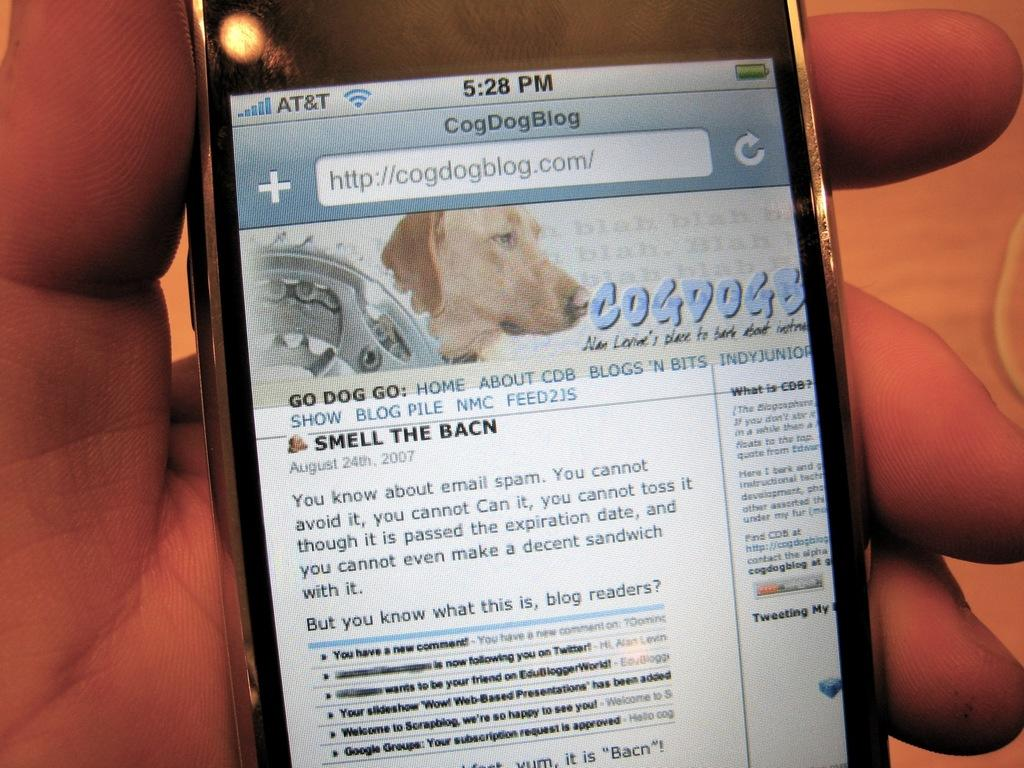What object is being held by a human hand in the image? There is a mobile in the image, and it is being held by a human hand. What is the primary function of the mobile in the image? The mobile is being used to display text visible on the mobile screen. What type of lumber is being used to construct the mobile in the image? There is no reference to lumber or any construction materials in the image; it features a mobile being held by a human hand. How does the map on the mobile screen show the location of the nearest coffee shop? There is no map or any indication of a coffee shop in the image; it only shows a mobile being held by a human hand with text visible on the screen. 